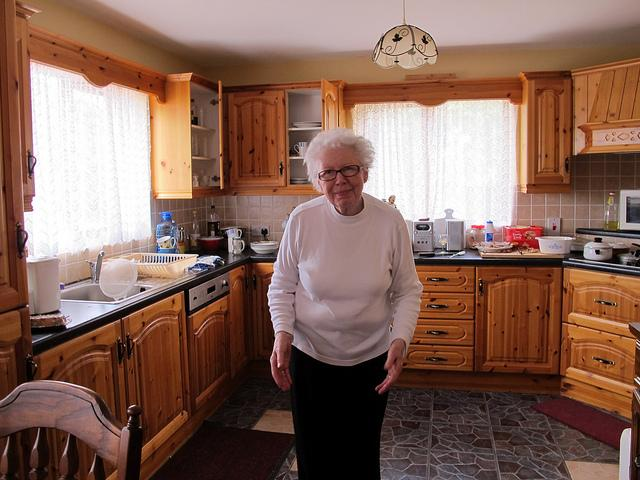Which term would best describe this woman? elderly 